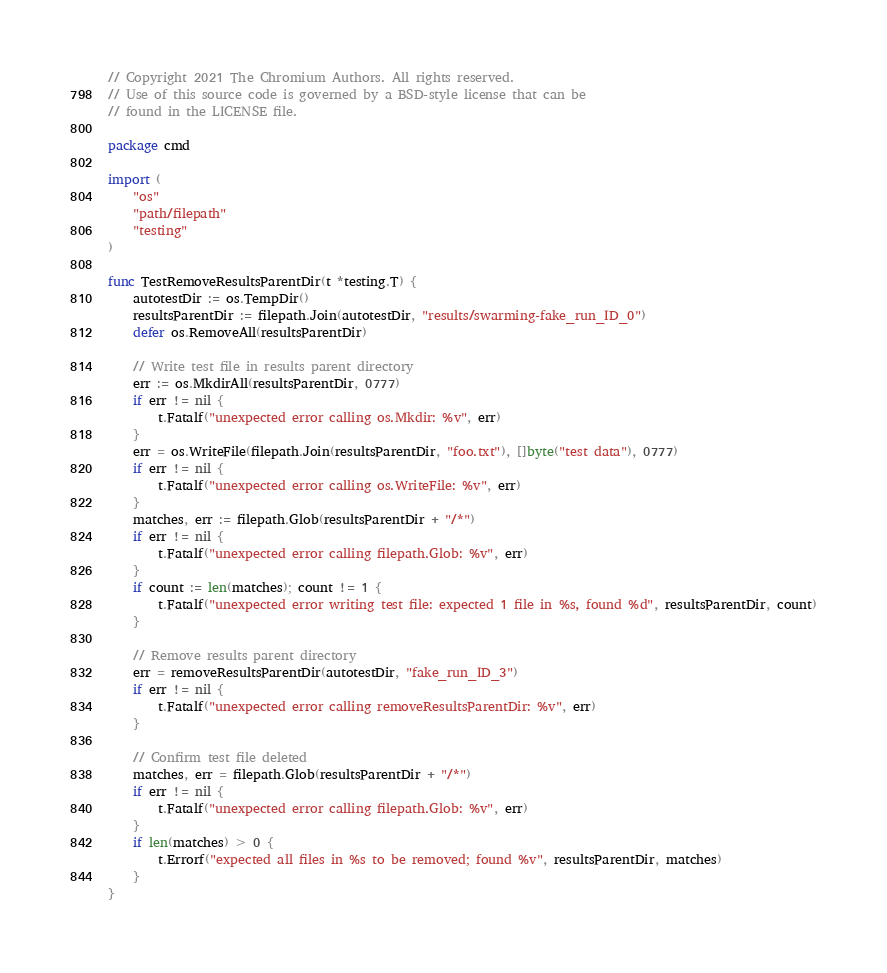Convert code to text. <code><loc_0><loc_0><loc_500><loc_500><_Go_>// Copyright 2021 The Chromium Authors. All rights reserved.
// Use of this source code is governed by a BSD-style license that can be
// found in the LICENSE file.

package cmd

import (
	"os"
	"path/filepath"
	"testing"
)

func TestRemoveResultsParentDir(t *testing.T) {
	autotestDir := os.TempDir()
	resultsParentDir := filepath.Join(autotestDir, "results/swarming-fake_run_ID_0")
	defer os.RemoveAll(resultsParentDir)

	// Write test file in results parent directory
	err := os.MkdirAll(resultsParentDir, 0777)
	if err != nil {
		t.Fatalf("unexpected error calling os.Mkdir: %v", err)
	}
	err = os.WriteFile(filepath.Join(resultsParentDir, "foo.txt"), []byte("test data"), 0777)
	if err != nil {
		t.Fatalf("unexpected error calling os.WriteFile: %v", err)
	}
	matches, err := filepath.Glob(resultsParentDir + "/*")
	if err != nil {
		t.Fatalf("unexpected error calling filepath.Glob: %v", err)
	}
	if count := len(matches); count != 1 {
		t.Fatalf("unexpected error writing test file: expected 1 file in %s, found %d", resultsParentDir, count)
	}

	// Remove results parent directory
	err = removeResultsParentDir(autotestDir, "fake_run_ID_3")
	if err != nil {
		t.Fatalf("unexpected error calling removeResultsParentDir: %v", err)
	}

	// Confirm test file deleted
	matches, err = filepath.Glob(resultsParentDir + "/*")
	if err != nil {
		t.Fatalf("unexpected error calling filepath.Glob: %v", err)
	}
	if len(matches) > 0 {
		t.Errorf("expected all files in %s to be removed; found %v", resultsParentDir, matches)
	}
}
</code> 